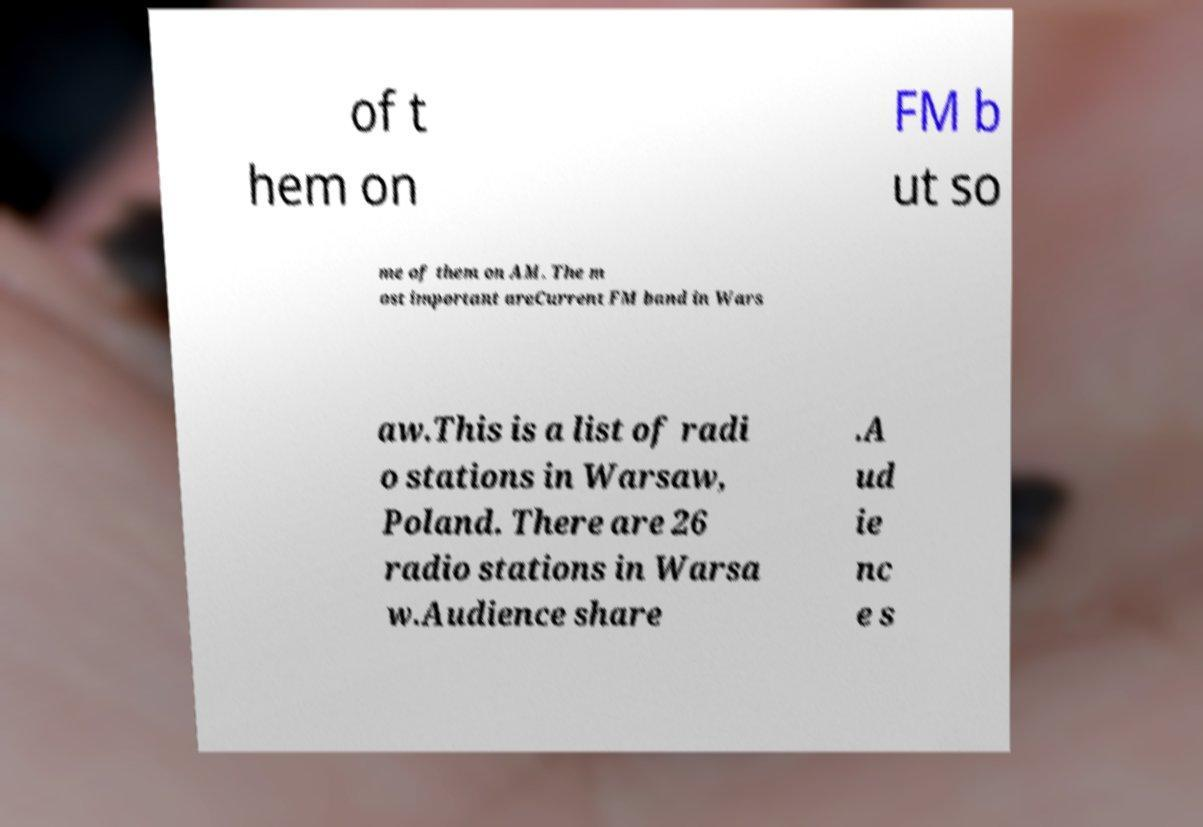Could you assist in decoding the text presented in this image and type it out clearly? of t hem on FM b ut so me of them on AM. The m ost important areCurrent FM band in Wars aw.This is a list of radi o stations in Warsaw, Poland. There are 26 radio stations in Warsa w.Audience share .A ud ie nc e s 